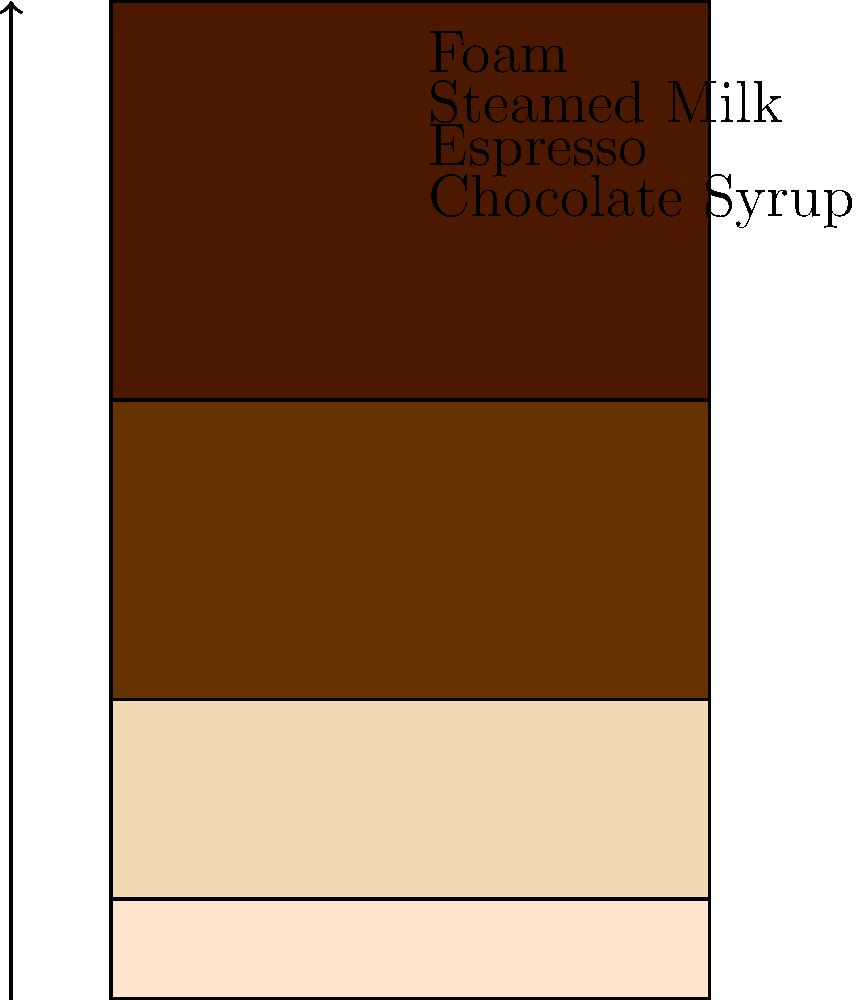In the "Audrey Hepburn Elegant Espresso" drink, what is the ratio of espresso to steamed milk? To determine the ratio of espresso to steamed milk in the "Audrey Hepburn Elegant Espresso" drink, we need to follow these steps:

1. Identify the layers in the drink from bottom to top:
   - Chocolate Syrup
   - Espresso
   - Steamed Milk
   - Foam

2. Locate the proportions for espresso and steamed milk:
   - Espresso: 0.3 (30% of the drink)
   - Steamed Milk: 0.2 (20% of the drink)

3. Express the ratio of espresso to steamed milk:
   $\frac{\text{Espresso}}{\text{Steamed Milk}} = \frac{0.3}{0.2} = \frac{3}{2}$

4. Simplify the ratio:
   $\frac{3}{2} = 1.5 : 1$

Therefore, the ratio of espresso to steamed milk in the "Audrey Hepburn Elegant Espresso" drink is 1.5:1 or 3:2.
Answer: 3:2 